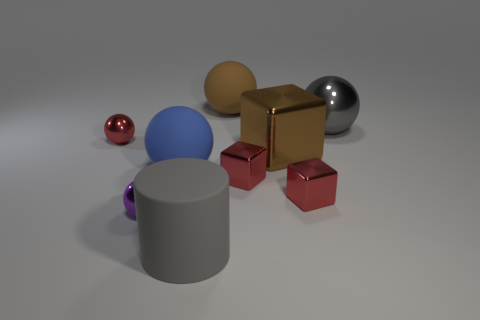What is the color of the matte cylinder that is the same size as the gray metallic thing?
Ensure brevity in your answer.  Gray. What is the color of the matte sphere in front of the gray sphere right of the brown shiny cube?
Your answer should be compact. Blue. There is a big object left of the large gray rubber cylinder; is it the same color as the big shiny cube?
Provide a short and direct response. No. There is a big gray object to the left of the metal sphere that is right of the matte ball that is left of the gray matte cylinder; what is its shape?
Offer a terse response. Cylinder. How many small red blocks are in front of the red sphere on the left side of the purple object?
Your answer should be very brief. 2. Do the gray cylinder and the purple ball have the same material?
Your response must be concise. No. There is a metal cube behind the big matte ball in front of the large shiny sphere; how many red metal objects are behind it?
Keep it short and to the point. 1. What is the color of the tiny sphere that is on the left side of the purple shiny object?
Make the answer very short. Red. There is a purple shiny thing that is to the left of the big gray thing behind the gray matte cylinder; what shape is it?
Provide a short and direct response. Sphere. Is the color of the large matte cylinder the same as the large metal ball?
Provide a short and direct response. Yes. 